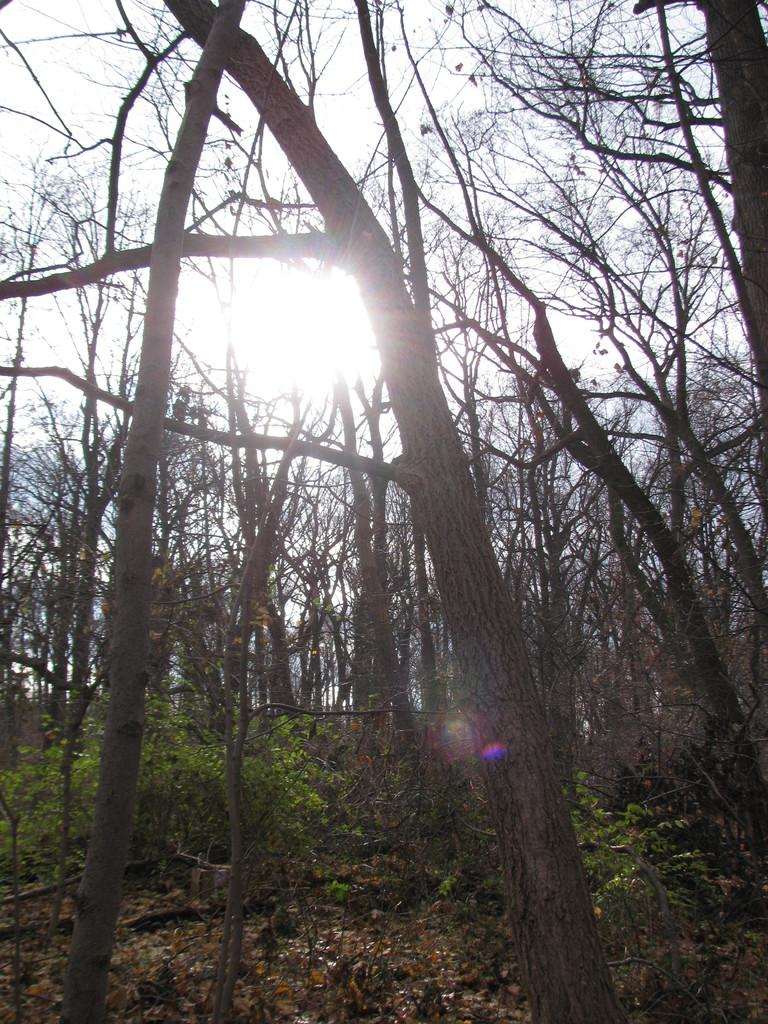What type of living organisms can be seen in the image? Plants and dry trees are visible in the image. Can you describe the celestial body visible in the image? The sun is visible in the image. What part of the natural environment is visible in the image? The sky is visible in the background of the image. What type of jeans is the existence wearing in the image? There is no reference to any existence or jeans in the image; it features plants, dry trees, the sun, and the sky. 